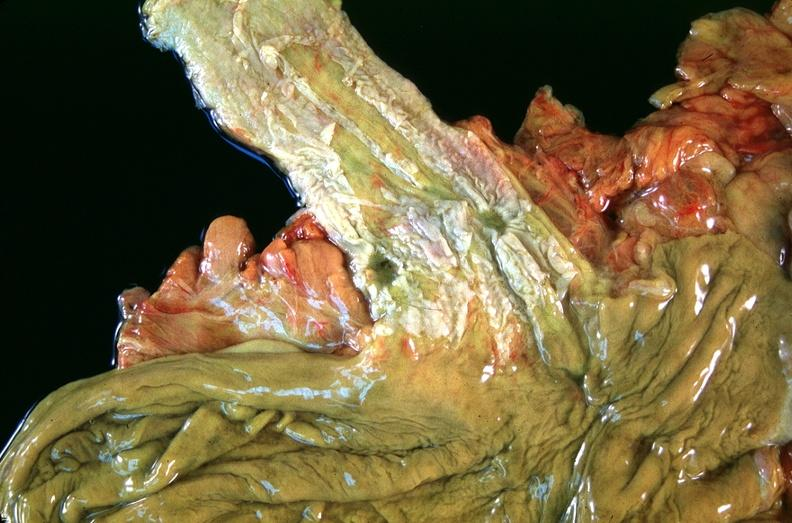why does this image show esophogus, varices?
Answer the question using a single word or phrase. Due to portal hypertension from cirrhosis hcv 